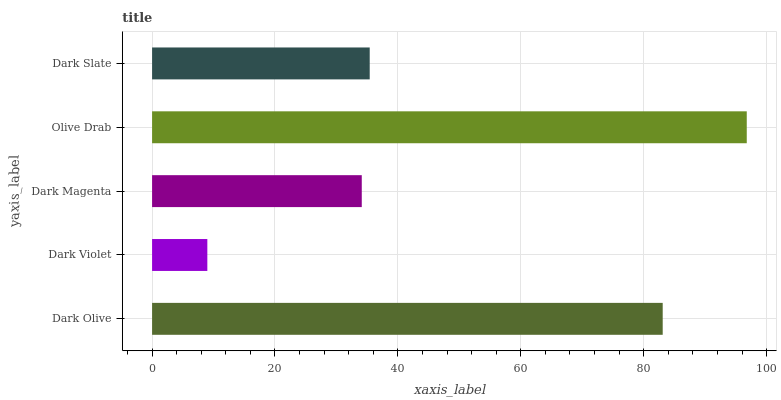Is Dark Violet the minimum?
Answer yes or no. Yes. Is Olive Drab the maximum?
Answer yes or no. Yes. Is Dark Magenta the minimum?
Answer yes or no. No. Is Dark Magenta the maximum?
Answer yes or no. No. Is Dark Magenta greater than Dark Violet?
Answer yes or no. Yes. Is Dark Violet less than Dark Magenta?
Answer yes or no. Yes. Is Dark Violet greater than Dark Magenta?
Answer yes or no. No. Is Dark Magenta less than Dark Violet?
Answer yes or no. No. Is Dark Slate the high median?
Answer yes or no. Yes. Is Dark Slate the low median?
Answer yes or no. Yes. Is Olive Drab the high median?
Answer yes or no. No. Is Dark Olive the low median?
Answer yes or no. No. 